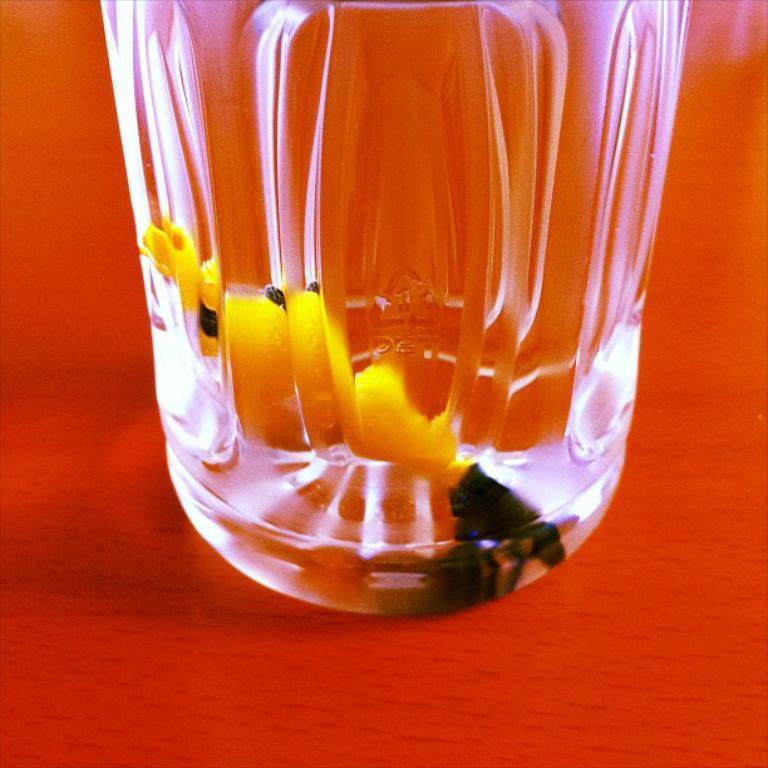Describe this image in one or two sentences. In this image I can see it looks like a glass, there is something in it. 